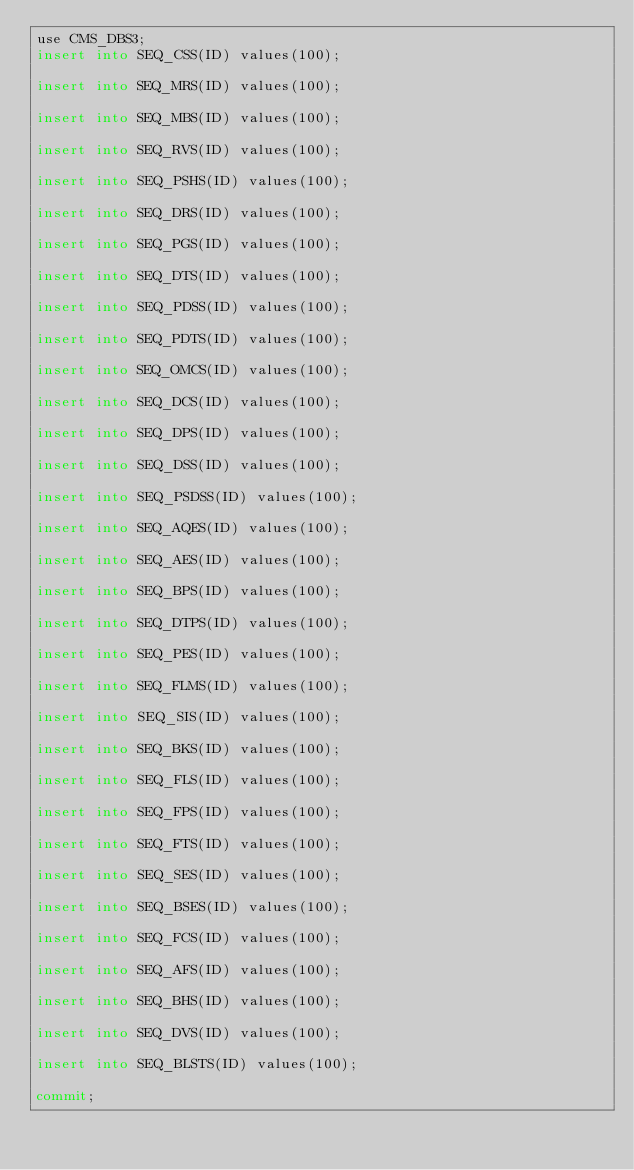Convert code to text. <code><loc_0><loc_0><loc_500><loc_500><_SQL_>use CMS_DBS3;
insert into SEQ_CSS(ID) values(100);

insert into SEQ_MRS(ID) values(100);

insert into SEQ_MBS(ID) values(100);

insert into SEQ_RVS(ID) values(100); 

insert into SEQ_PSHS(ID) values(100);

insert into SEQ_DRS(ID) values(100);

insert into SEQ_PGS(ID) values(100);

insert into SEQ_DTS(ID) values(100);

insert into SEQ_PDSS(ID) values(100);

insert into SEQ_PDTS(ID) values(100);

insert into SEQ_OMCS(ID) values(100);

insert into SEQ_DCS(ID) values(100);

insert into SEQ_DPS(ID) values(100);

insert into SEQ_DSS(ID) values(100);

insert into SEQ_PSDSS(ID) values(100);

insert into SEQ_AQES(ID) values(100);

insert into SEQ_AES(ID) values(100);

insert into SEQ_BPS(ID) values(100);

insert into SEQ_DTPS(ID) values(100);

insert into SEQ_PES(ID) values(100);

insert into SEQ_FLMS(ID) values(100);

insert into SEQ_SIS(ID) values(100);

insert into SEQ_BKS(ID) values(100);

insert into SEQ_FLS(ID) values(100);

insert into SEQ_FPS(ID) values(100);

insert into SEQ_FTS(ID) values(100);

insert into SEQ_SES(ID) values(100);

insert into SEQ_BSES(ID) values(100);

insert into SEQ_FCS(ID) values(100);

insert into SEQ_AFS(ID) values(100);

insert into SEQ_BHS(ID) values(100);

insert into SEQ_DVS(ID) values(100);

insert into SEQ_BLSTS(ID) values(100);

commit;
</code> 